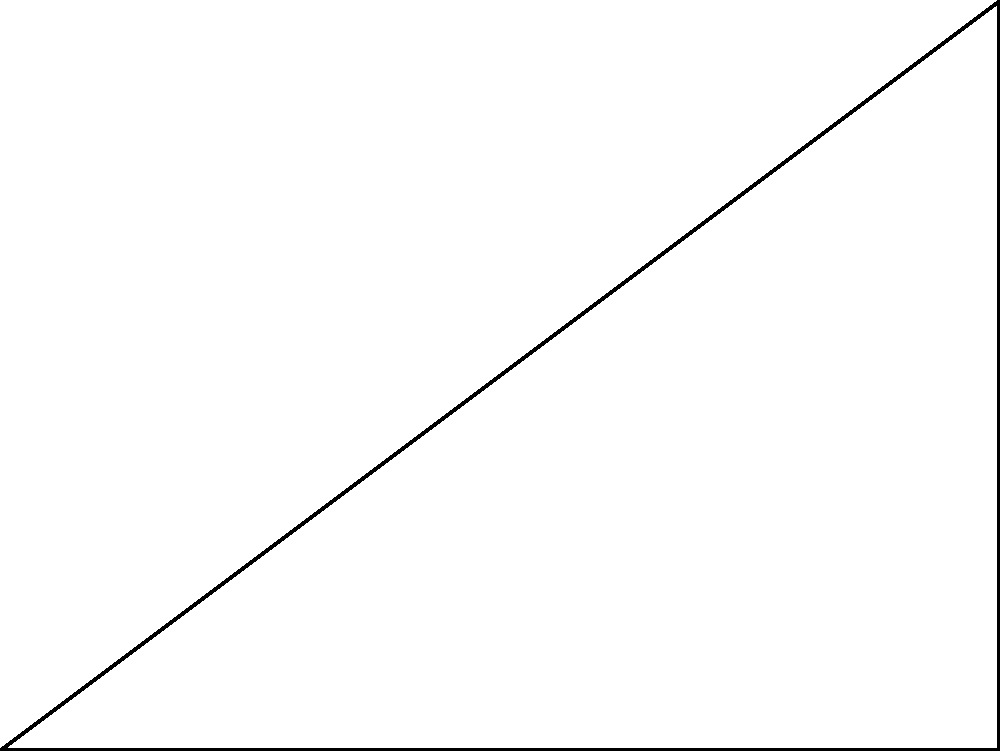As part of a local bridge construction project, you need to determine the length of a support beam. The beam forms the hypotenuse of a right triangle, where the base of the triangle is 30 meters and the height is 22.5 meters. Using right triangle trigonometry, calculate the length of the support beam to the nearest tenth of a meter. Let's approach this step-by-step:

1) We have a right triangle with:
   - Base (adjacent) = 30 m
   - Height (opposite) = 22.5 m
   - Hypotenuse (support beam) = unknown

2) We can use the Pythagorean theorem to find the length of the hypotenuse:

   $$a^2 + b^2 = c^2$$

   Where $a$ is the adjacent side, $b$ is the opposite side, and $c$ is the hypotenuse.

3) Substituting our known values:

   $$30^2 + 22.5^2 = c^2$$

4) Simplify:

   $$900 + 506.25 = c^2$$
   $$1406.25 = c^2$$

5) Take the square root of both sides:

   $$\sqrt{1406.25} = c$$

6) Calculate:

   $$c \approx 37.5$$

7) Rounding to the nearest tenth:

   $$c \approx 37.5 \text{ m}$$

Thus, the length of the support beam is approximately 37.5 meters.
Answer: 37.5 m 